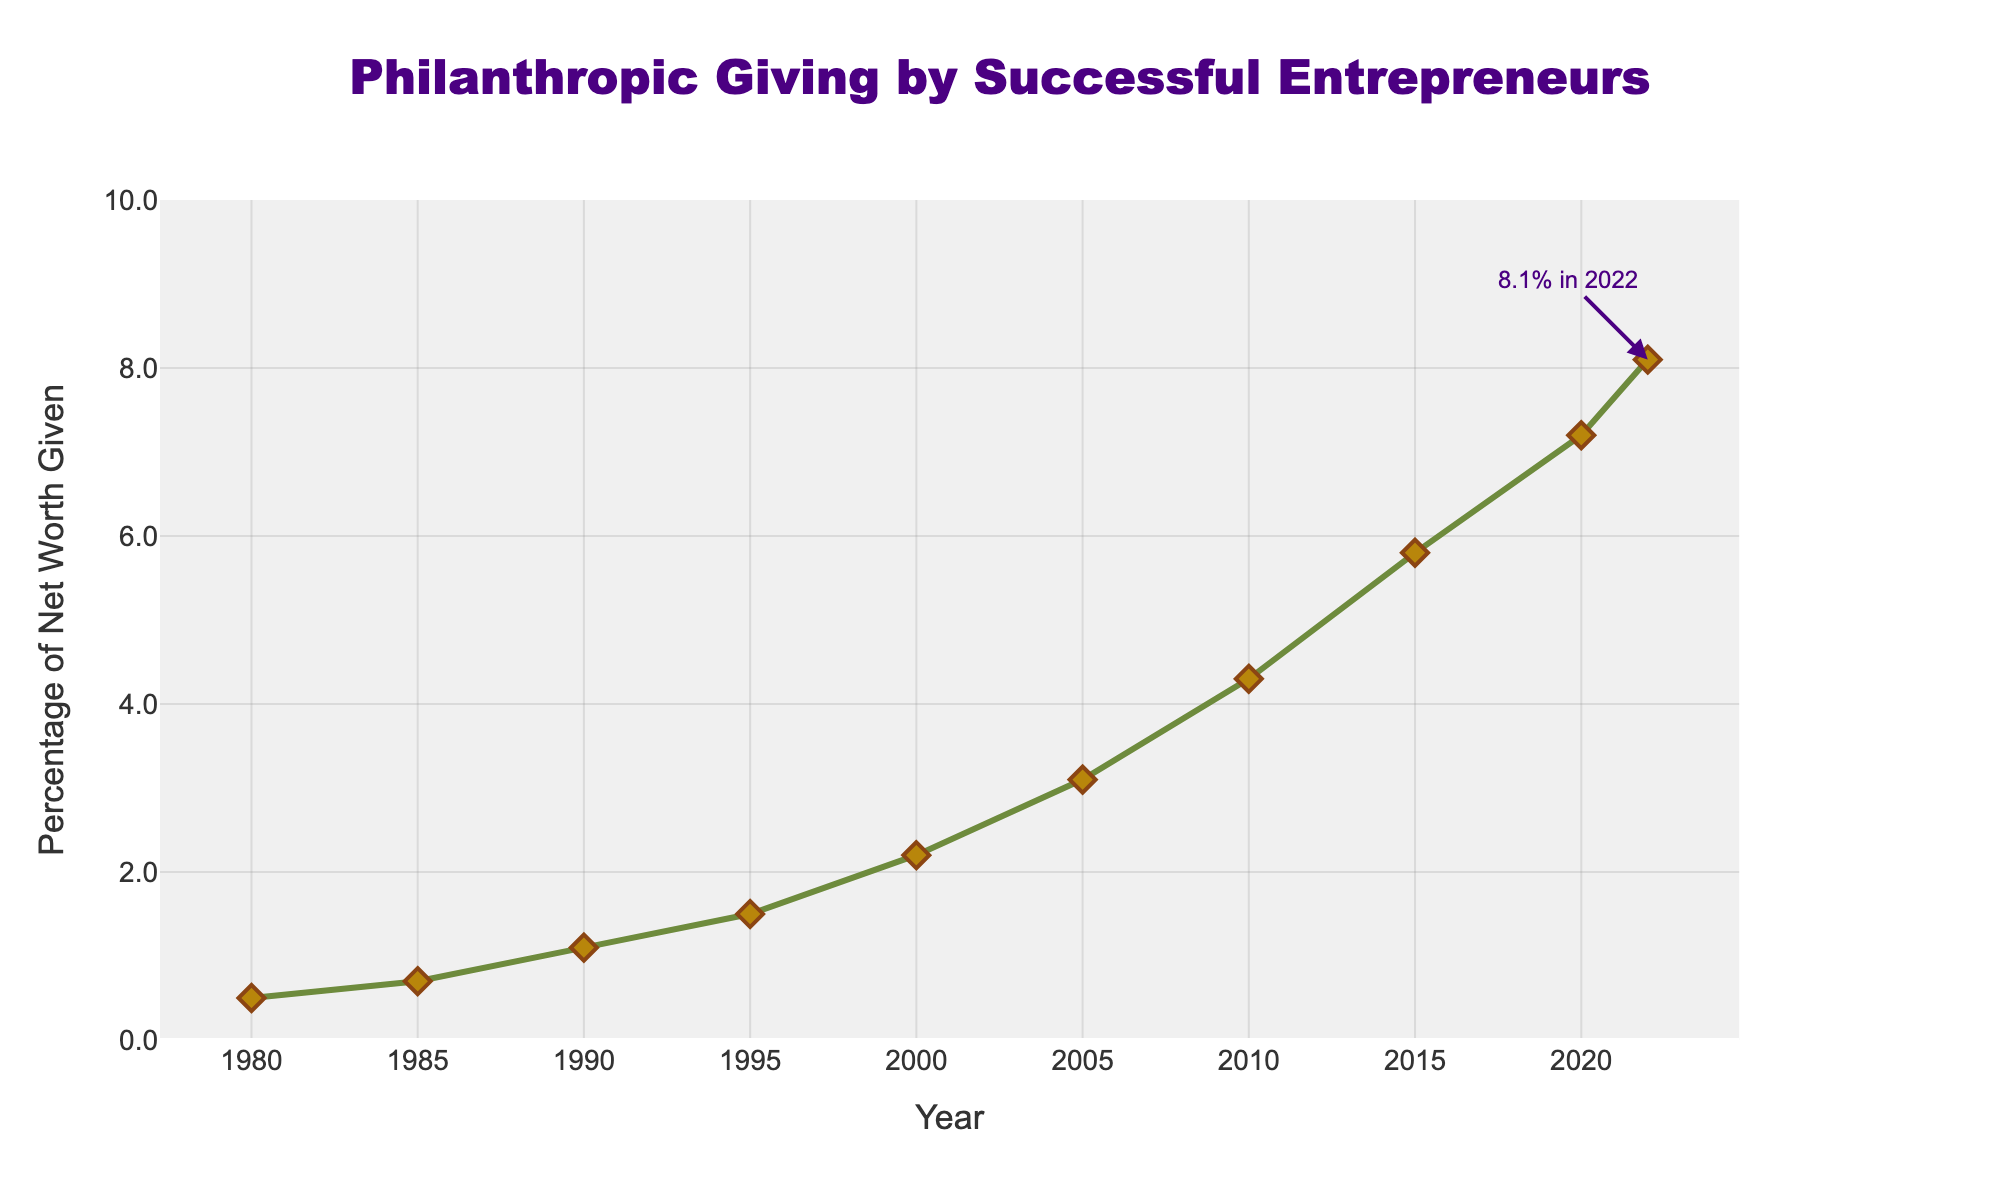What is the percentage of net worth given in the year 2010? To find the percentage of net worth given in 2010, you need to look at the data point on the x-axis labeled "2010" and check the corresponding y-value.
Answer: 4.3% Between which years did the largest increase in philanthropic giving as a percentage of net worth occur? The largest increase can be found by comparing the differences between consecutive data points. Subtract earlier years' percentages from later ones to determine the biggest jump. The largest increase happened between 2015 and 2020, where the percentage increased from 5.8% to 7.2%.
Answer: 2015 and 2020 What is the average percentage of net worth given for the first five years in the data? To calculate this, sum up the percentages for the years 1980, 1985, 1990, 1995, and 2000, then divide by 5. The sums are 0.5 + 0.7 + 1.1 + 1.5 + 2.2 = 6.0, so the average is 6.0 / 5 = 1.2%.
Answer: 1.2% How much did the percentage of net worth given increase between 1980 and 2022? Find the difference between the percentages for the years 2022 and 1980. This involves subtracting the 1980 percentage from the 2022 percentage, 8.1% - 0.5% = 7.6%.
Answer: 7.6% Which year saw the philanthropic giving percentage reach below 3% for the last time? To find this, identify the latest year on the x-axis before any percentage goes above 3%. This year is 2005, with a philanthropic giving percentage of 3.1% in 2005.
Answer: 2005 By how much did the philanthropic giving percentage increase from 2000 to 2005? Subtract the percentage in the year 2000 from the percentage in 2005. The increase is 3.1% - 2.2% = 0.9%.
Answer: 0.9% What is the median percentage of net worth given across all the years in the data? First, order the percentages: 0.5, 0.7, 1.1, 1.5, 2.2, 3.1, 4.3, 5.8, 7.2, 8.1. The median is the average of the middle two values (for an even number of values). Therefore, median = (2.2 + 3.1) / 2 = 2.65%.
Answer: 2.65% What is the color of the line representing the philanthropic giving percentage change? To answer, note the color used to plot the line on the figure representing philanthropic giving. The line is green.
Answer: Green What is the slope of the percentage increase between 2010 and 2015? Determine the slope by finding the change in percentage over the change in years from 2010 to 2015. Slope = (5.8% - 4.3%) / (2015 - 2010) = 1.5% / 5 years = 0.3% per year.
Answer: 0.3% per year 